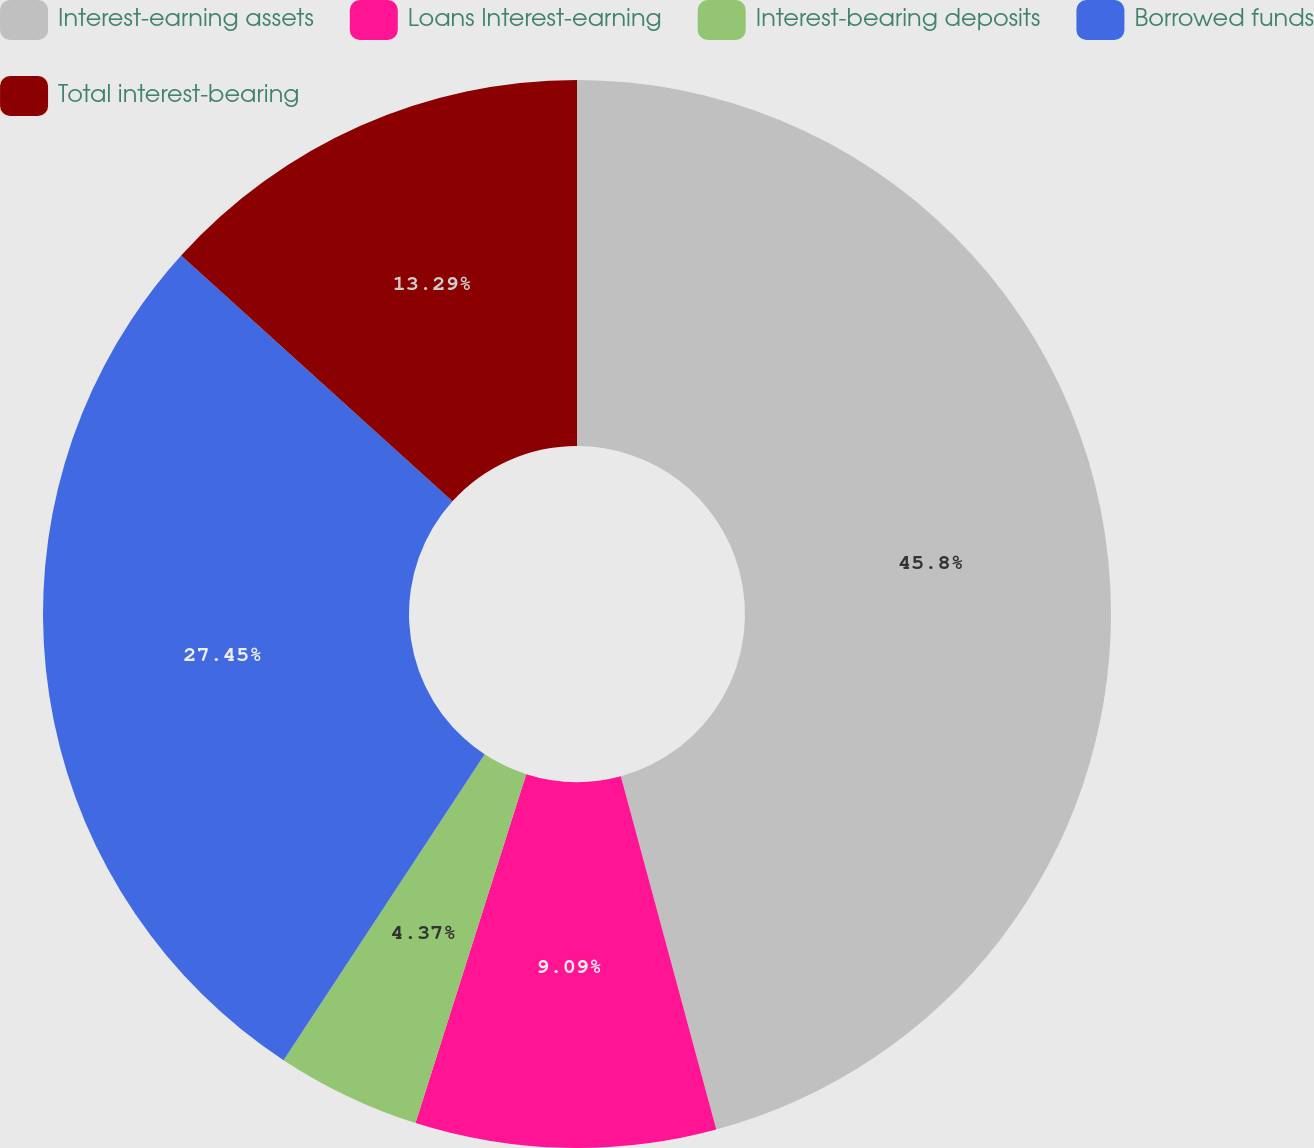Convert chart to OTSL. <chart><loc_0><loc_0><loc_500><loc_500><pie_chart><fcel>Interest-earning assets<fcel>Loans Interest-earning<fcel>Interest-bearing deposits<fcel>Borrowed funds<fcel>Total interest-bearing<nl><fcel>45.8%<fcel>9.09%<fcel>4.37%<fcel>27.45%<fcel>13.29%<nl></chart> 